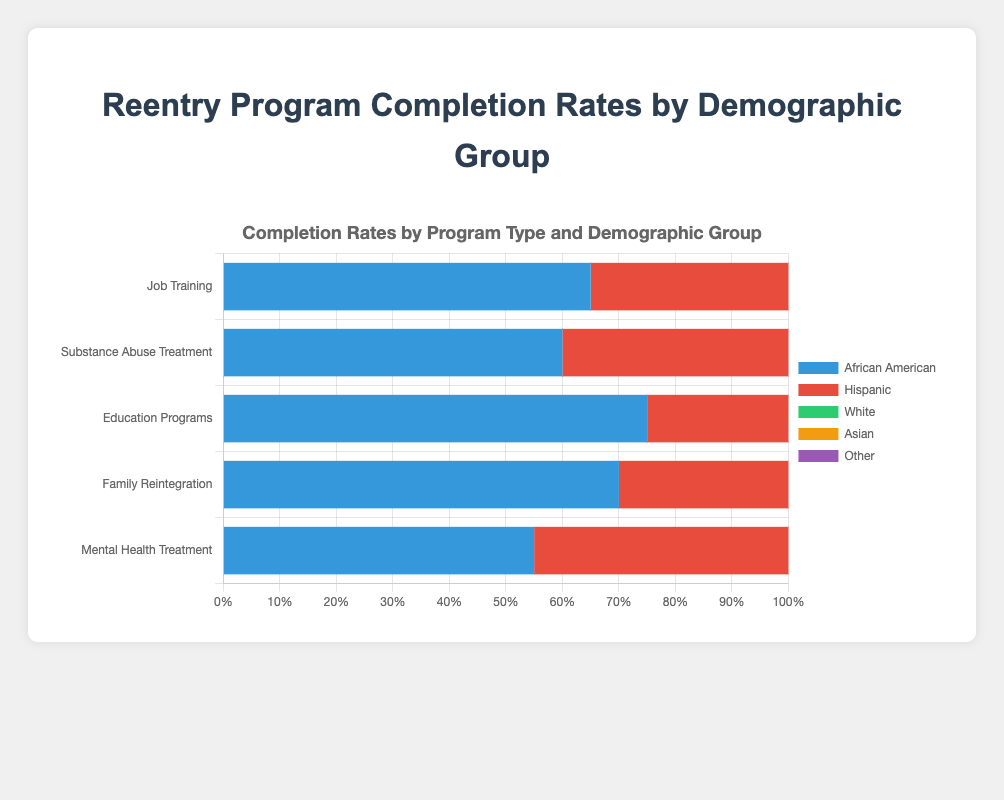Which demographic group has the lowest completion rate in Mental Health Treatment programs? Looking at the bar section corresponding to Mental Health Treatment, the African American group has the lowest completion rate, represented visually by the shortest bar segment.
Answer: African American Which program type has the highest completion rate for the Asian demographic group? Observing the stacked bars for the Asian group, the Education Programs bar has the highest completion rate, at 90%.
Answer: Education Programs What is the difference in completion rates between African American and Hispanic groups for Job Training programs? The African American group has a completion rate of 65% while the Hispanic group has a completion rate of 70%. The difference is 70% - 65%.
Answer: 5% In Substance Abuse Treatment programs, which group has a completion rate below 65%? In the Substance Abuse Treatment bar, the only group with a completion rate below 65% is the African American group.
Answer: African American Compare the completion rates of White and Asian groups for Family Reintegration programs. Which group has a higher rate and by how much? The White group has a completion rate of 80%, while the Asian group has 82%. The difference is 82% - 80%.
Answer: Asian, 2% What is the average completion rate of all demographic groups in Education Programs? Adding up the completion rates: (75% + 80% + 85% + 90% + 78%) = 408%. The average is 408% / 5.
Answer: 81.6% How much higher is the completion rate for the Asian group compared to the Other group in Substance Abuse Treatment programs? The Asian group has a rate of 85% and the Other group has a rate of 63%. The difference is 85% - 63%.
Answer: 22% In which program type is the completion rate for the "Other" group closest to 70%? The completion rate closest to 70% for the "Other" group is in the Family Reintegration program, where it is 73%.
Answer: Family Reintegration Which demographic group has the most consistent completion rate across all program types? Looking at the variation in bar segments for each demographic group across the programs, the White group's completion rates are: 75%, 70%, 85%, 80%, and 65%. This shows relatively consistent performance.
Answer: White Which program type has the lowest average completion rates across all demographic groups? Calculating the averages: 
Job Training (65% + 70% + 75% + 80% + 68%) / 5 = 71.6%,
Substance Abuse Treatment (60% + 65% + 70% + 85% + 63%) / 5 = 68.6%,
Education Programs (75% + 80% + 85% + 90% + 78%) / 5 = 81.6%,
Family Reintegration (70% + 75% + 80% + 82% + 73%) / 5 = 76%,
Mental Health Treatment (55% + 60% + 65% + 75% + 58%) / 5 = 62.6%.
The lowest is for Mental Health Treatment.
Answer: Mental Health Treatment 